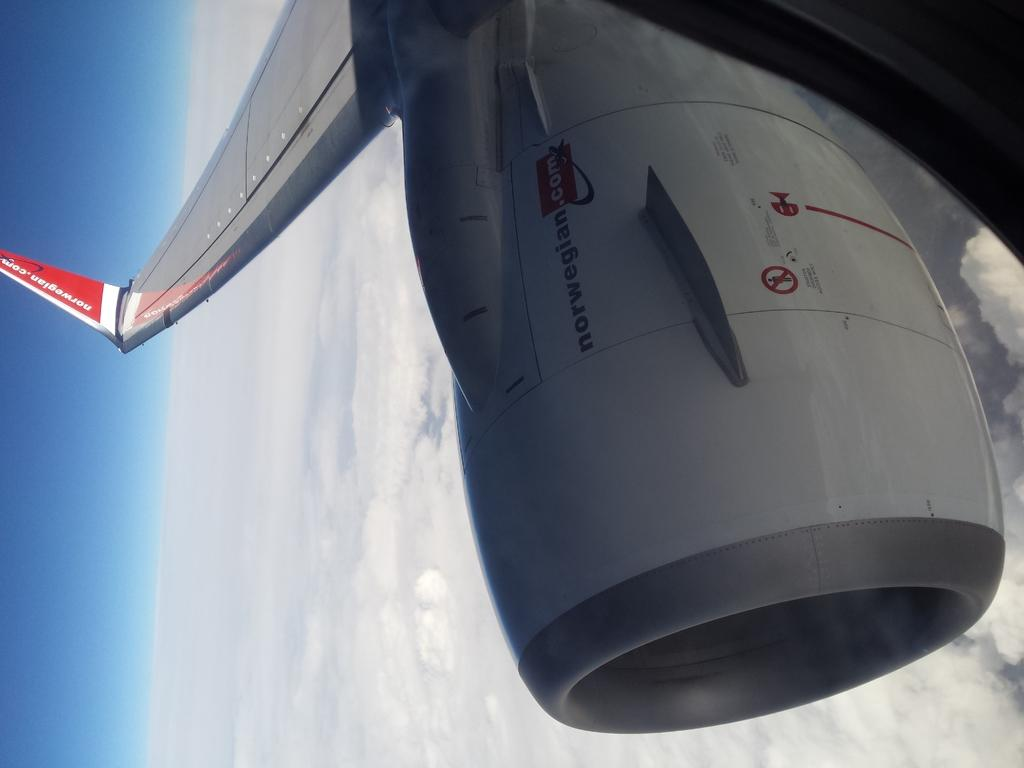<image>
Render a clear and concise summary of the photo. An airplane with the advertisement norwegian.com on it. 